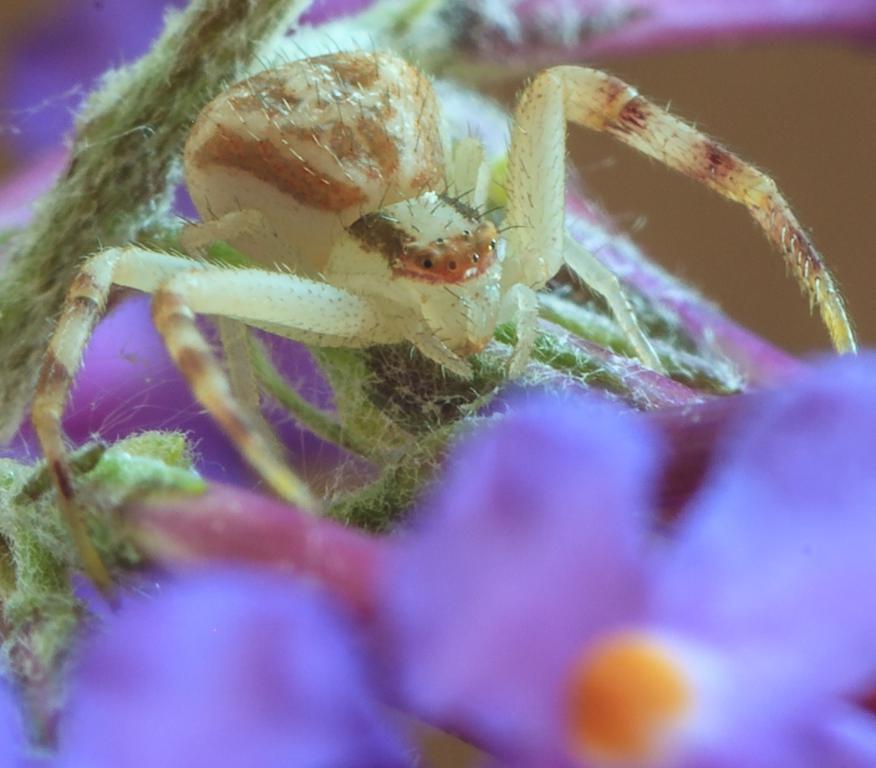Can you describe this image briefly? In this picture I can see the insect. I can see the flower on the right side. 